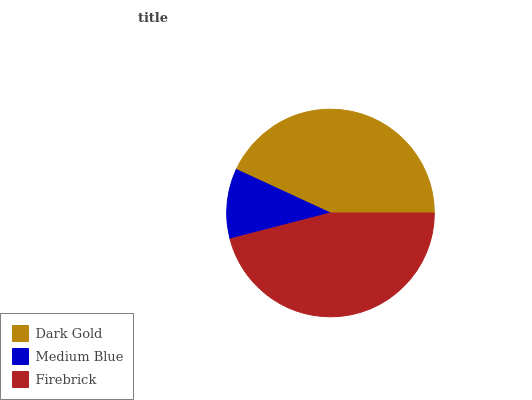Is Medium Blue the minimum?
Answer yes or no. Yes. Is Firebrick the maximum?
Answer yes or no. Yes. Is Firebrick the minimum?
Answer yes or no. No. Is Medium Blue the maximum?
Answer yes or no. No. Is Firebrick greater than Medium Blue?
Answer yes or no. Yes. Is Medium Blue less than Firebrick?
Answer yes or no. Yes. Is Medium Blue greater than Firebrick?
Answer yes or no. No. Is Firebrick less than Medium Blue?
Answer yes or no. No. Is Dark Gold the high median?
Answer yes or no. Yes. Is Dark Gold the low median?
Answer yes or no. Yes. Is Firebrick the high median?
Answer yes or no. No. Is Medium Blue the low median?
Answer yes or no. No. 